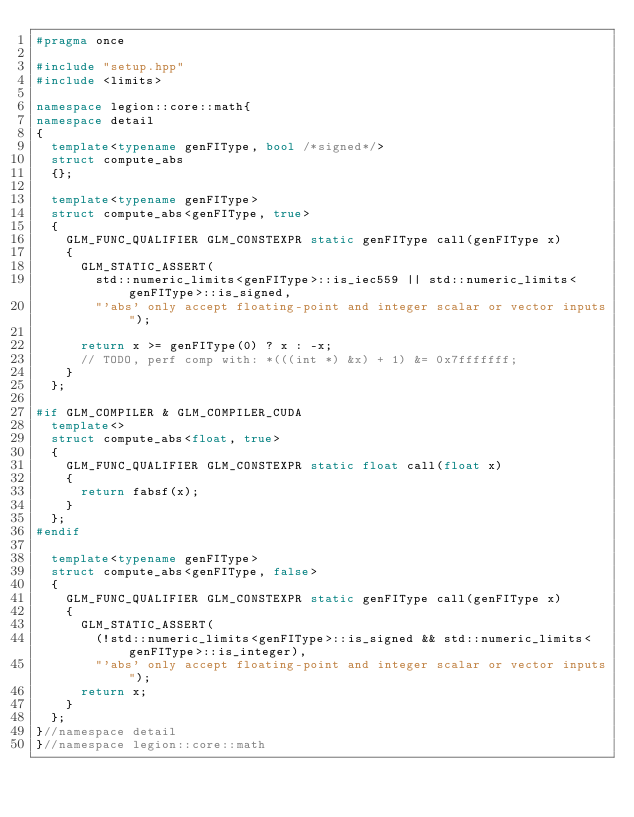<code> <loc_0><loc_0><loc_500><loc_500><_C++_>#pragma once

#include "setup.hpp"
#include <limits>

namespace legion::core::math{
namespace detail
{
	template<typename genFIType, bool /*signed*/>
	struct compute_abs
	{};

	template<typename genFIType>
	struct compute_abs<genFIType, true>
	{
		GLM_FUNC_QUALIFIER GLM_CONSTEXPR static genFIType call(genFIType x)
		{
			GLM_STATIC_ASSERT(
				std::numeric_limits<genFIType>::is_iec559 || std::numeric_limits<genFIType>::is_signed,
				"'abs' only accept floating-point and integer scalar or vector inputs");

			return x >= genFIType(0) ? x : -x;
			// TODO, perf comp with: *(((int *) &x) + 1) &= 0x7fffffff;
		}
	};

#if GLM_COMPILER & GLM_COMPILER_CUDA
	template<>
	struct compute_abs<float, true>
	{
		GLM_FUNC_QUALIFIER GLM_CONSTEXPR static float call(float x)
		{
			return fabsf(x);
		}
	};
#endif

	template<typename genFIType>
	struct compute_abs<genFIType, false>
	{
		GLM_FUNC_QUALIFIER GLM_CONSTEXPR static genFIType call(genFIType x)
		{
			GLM_STATIC_ASSERT(
				(!std::numeric_limits<genFIType>::is_signed && std::numeric_limits<genFIType>::is_integer),
				"'abs' only accept floating-point and integer scalar or vector inputs");
			return x;
		}
	};
}//namespace detail
}//namespace legion::core::math
</code> 